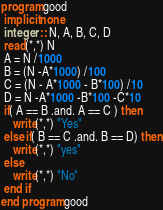Convert code to text. <code><loc_0><loc_0><loc_500><loc_500><_FORTRAN_>program good
 implicit none
 integer :: N, A, B, C, D
 read(*,*) N
 A = N /1000
 B = (N -A*1000) /100
 C = (N - A*1000 - B*100) /10
 D = N -A*1000 -B*100 -C*10
 if( A == B .and. A == C ) then
 	write(*,*) "Yes"
 else if( B == C .and. B == D) then
 	write(*,*) "yes"
 else
 	write(*,*) "No"
 end if
end program good</code> 